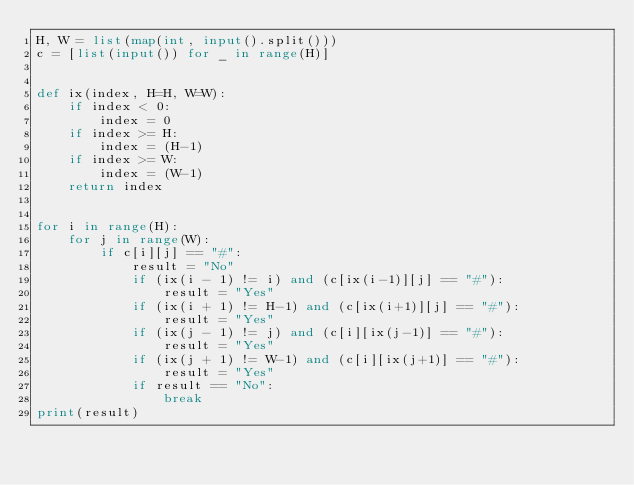<code> <loc_0><loc_0><loc_500><loc_500><_Python_>H, W = list(map(int, input().split()))
c = [list(input()) for _ in range(H)]


def ix(index, H=H, W=W):
    if index < 0:
        index = 0
    if index >= H:
        index = (H-1)
    if index >= W:
        index = (W-1)
    return index


for i in range(H):
    for j in range(W):
        if c[i][j] == "#":
            result = "No"
            if (ix(i - 1) != i) and (c[ix(i-1)][j] == "#"):
                result = "Yes"
            if (ix(i + 1) != H-1) and (c[ix(i+1)][j] == "#"):
                result = "Yes"
            if (ix(j - 1) != j) and (c[i][ix(j-1)] == "#"):
                result = "Yes"
            if (ix(j + 1) != W-1) and (c[i][ix(j+1)] == "#"):
                result = "Yes"
            if result == "No":
                break
print(result)
</code> 